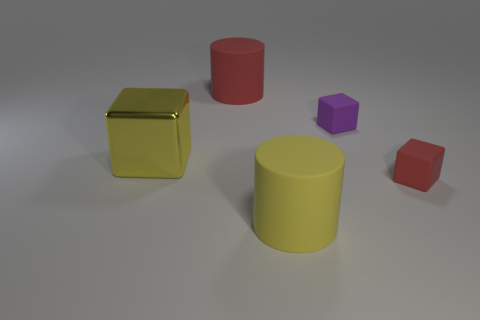Subtract all small cubes. How many cubes are left? 1 Add 5 red blocks. How many objects exist? 10 Subtract 2 cubes. How many cubes are left? 1 Subtract all red cylinders. How many cylinders are left? 1 Subtract all cylinders. How many objects are left? 3 Subtract all brown cubes. Subtract all yellow balls. How many cubes are left? 3 Subtract all brown cubes. How many gray cylinders are left? 0 Subtract all yellow matte objects. Subtract all tiny brown matte blocks. How many objects are left? 4 Add 1 big red rubber cylinders. How many big red rubber cylinders are left? 2 Add 4 yellow matte objects. How many yellow matte objects exist? 5 